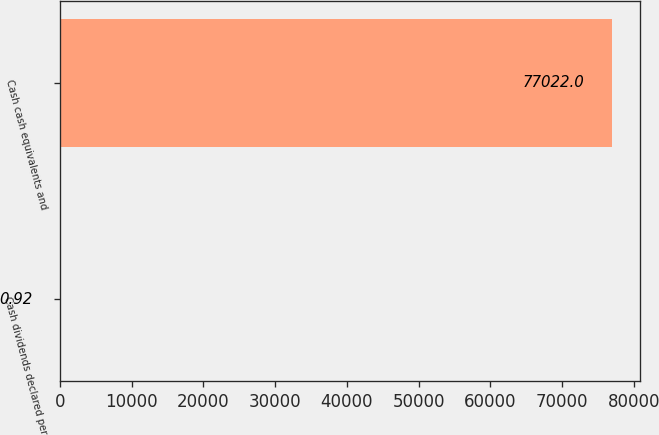Convert chart to OTSL. <chart><loc_0><loc_0><loc_500><loc_500><bar_chart><fcel>Cash dividends declared per<fcel>Cash cash equivalents and<nl><fcel>0.92<fcel>77022<nl></chart> 